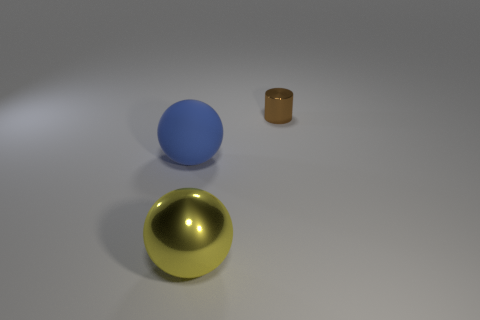Add 2 small blue matte spheres. How many objects exist? 5 Subtract all spheres. How many objects are left? 1 Add 2 yellow balls. How many yellow balls exist? 3 Subtract 0 purple cubes. How many objects are left? 3 Subtract all brown metallic cylinders. Subtract all large yellow metal things. How many objects are left? 1 Add 1 tiny brown cylinders. How many tiny brown cylinders are left? 2 